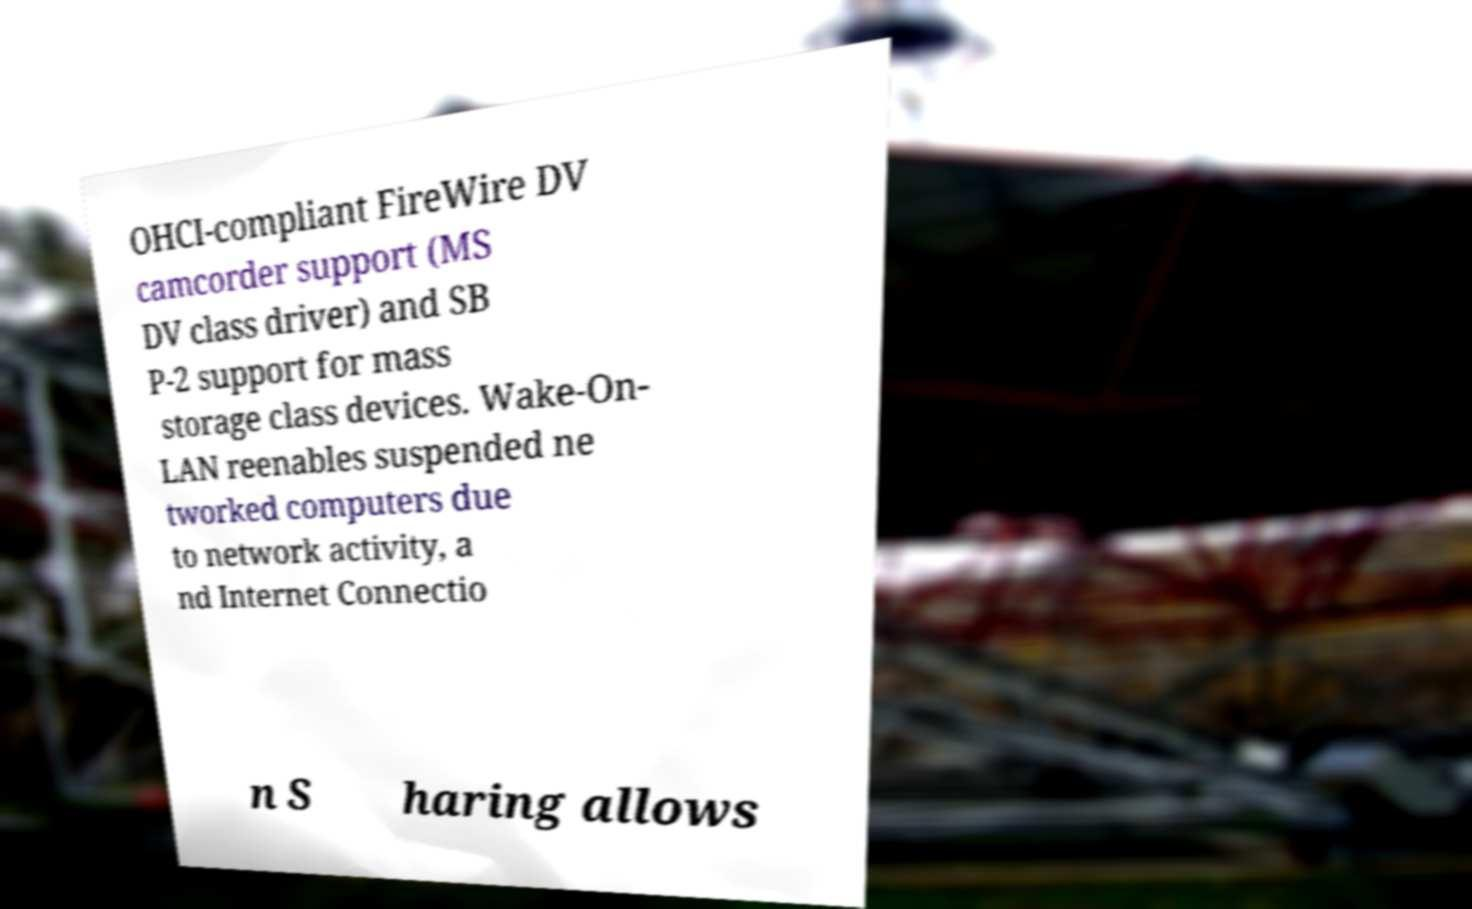Please read and relay the text visible in this image. What does it say? OHCI-compliant FireWire DV camcorder support (MS DV class driver) and SB P-2 support for mass storage class devices. Wake-On- LAN reenables suspended ne tworked computers due to network activity, a nd Internet Connectio n S haring allows 